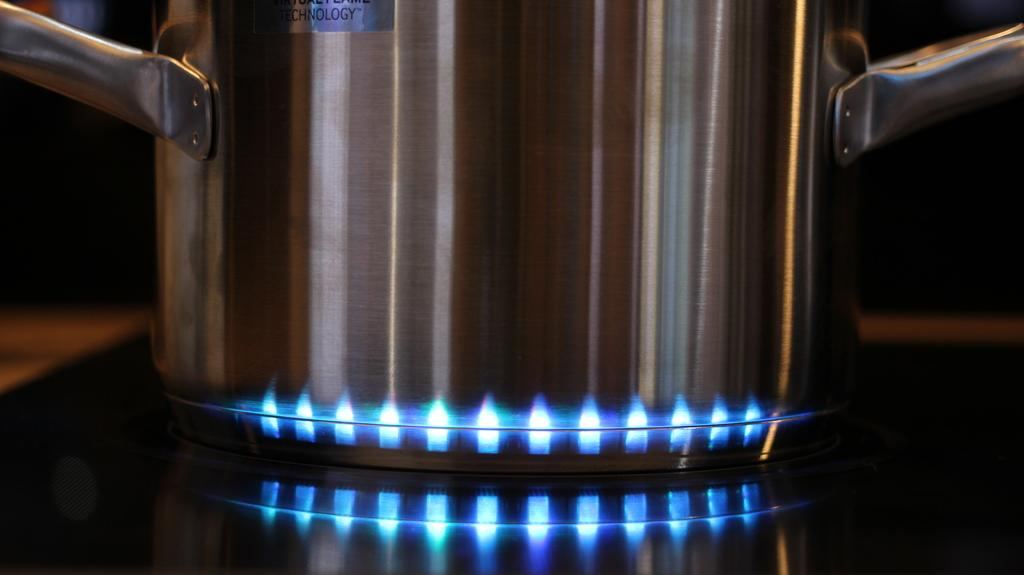What object can be seen in the image? There is an utensil in the image. Where is the utensil located? The utensil is on a gas stove. What type of harmony can be heard in the image? There is no audible sound or harmony present in the image, as it only features a utensil on a gas stove. 